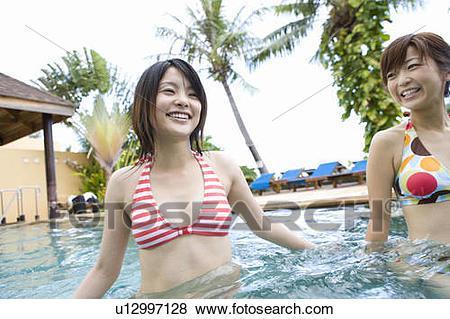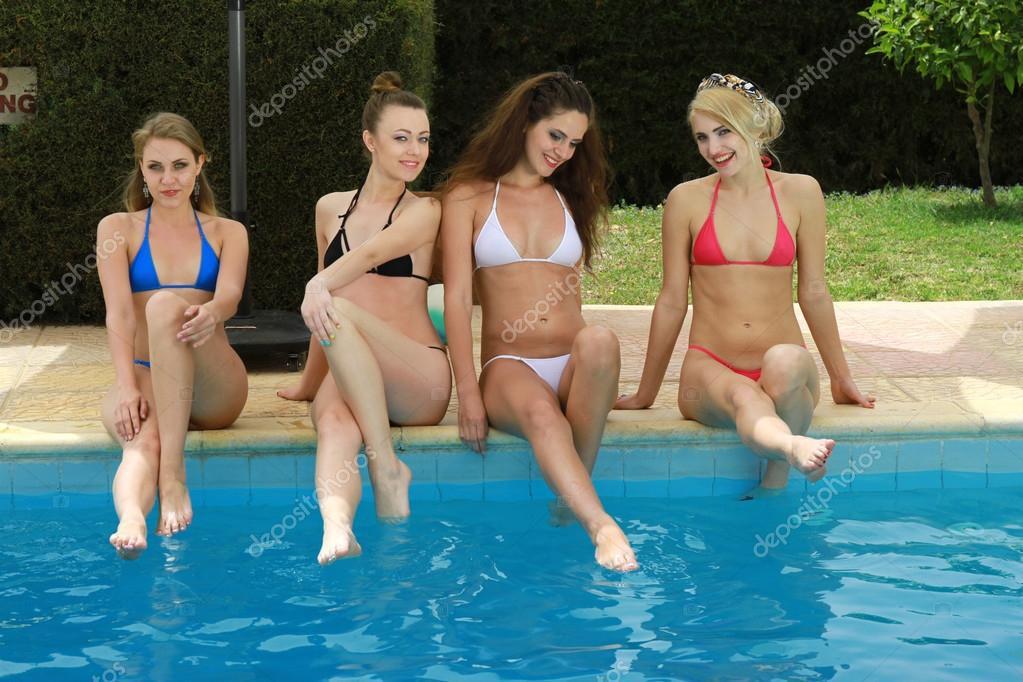The first image is the image on the left, the second image is the image on the right. Given the left and right images, does the statement "The left image contains exactly one person in the water." hold true? Answer yes or no. No. The first image is the image on the left, the second image is the image on the right. Assess this claim about the two images: "Four models in solid-colored bikinis are sitting on the edge of a pool dipping their toes in the water.". Correct or not? Answer yes or no. Yes. 